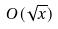<formula> <loc_0><loc_0><loc_500><loc_500>O ( \sqrt { x } )</formula> 